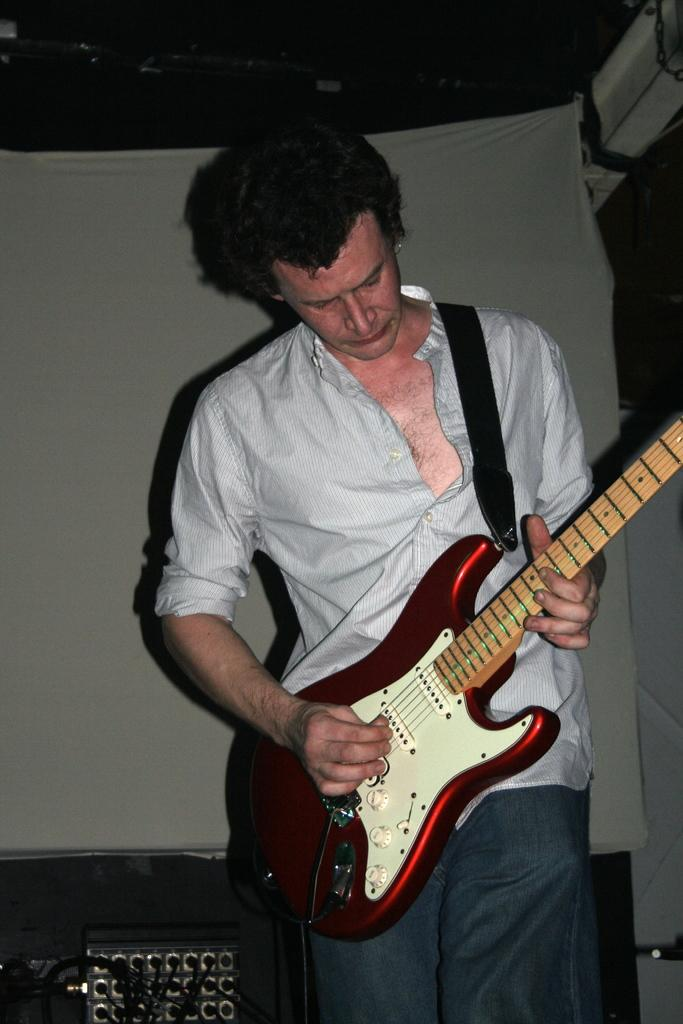Who is the main subject in the image? There is a man in the image. What is the man doing in the image? The man is standing in the image. What is the man holding in the image? The man is holding a guitar in the image. What is the man wearing in the image? The man is wearing a shirt in the image. What is the process of extracting zinc from the guitar in the image? There is no process of extracting zinc from the guitar in the image, as the guitar is a musical instrument and not a source of zinc. 